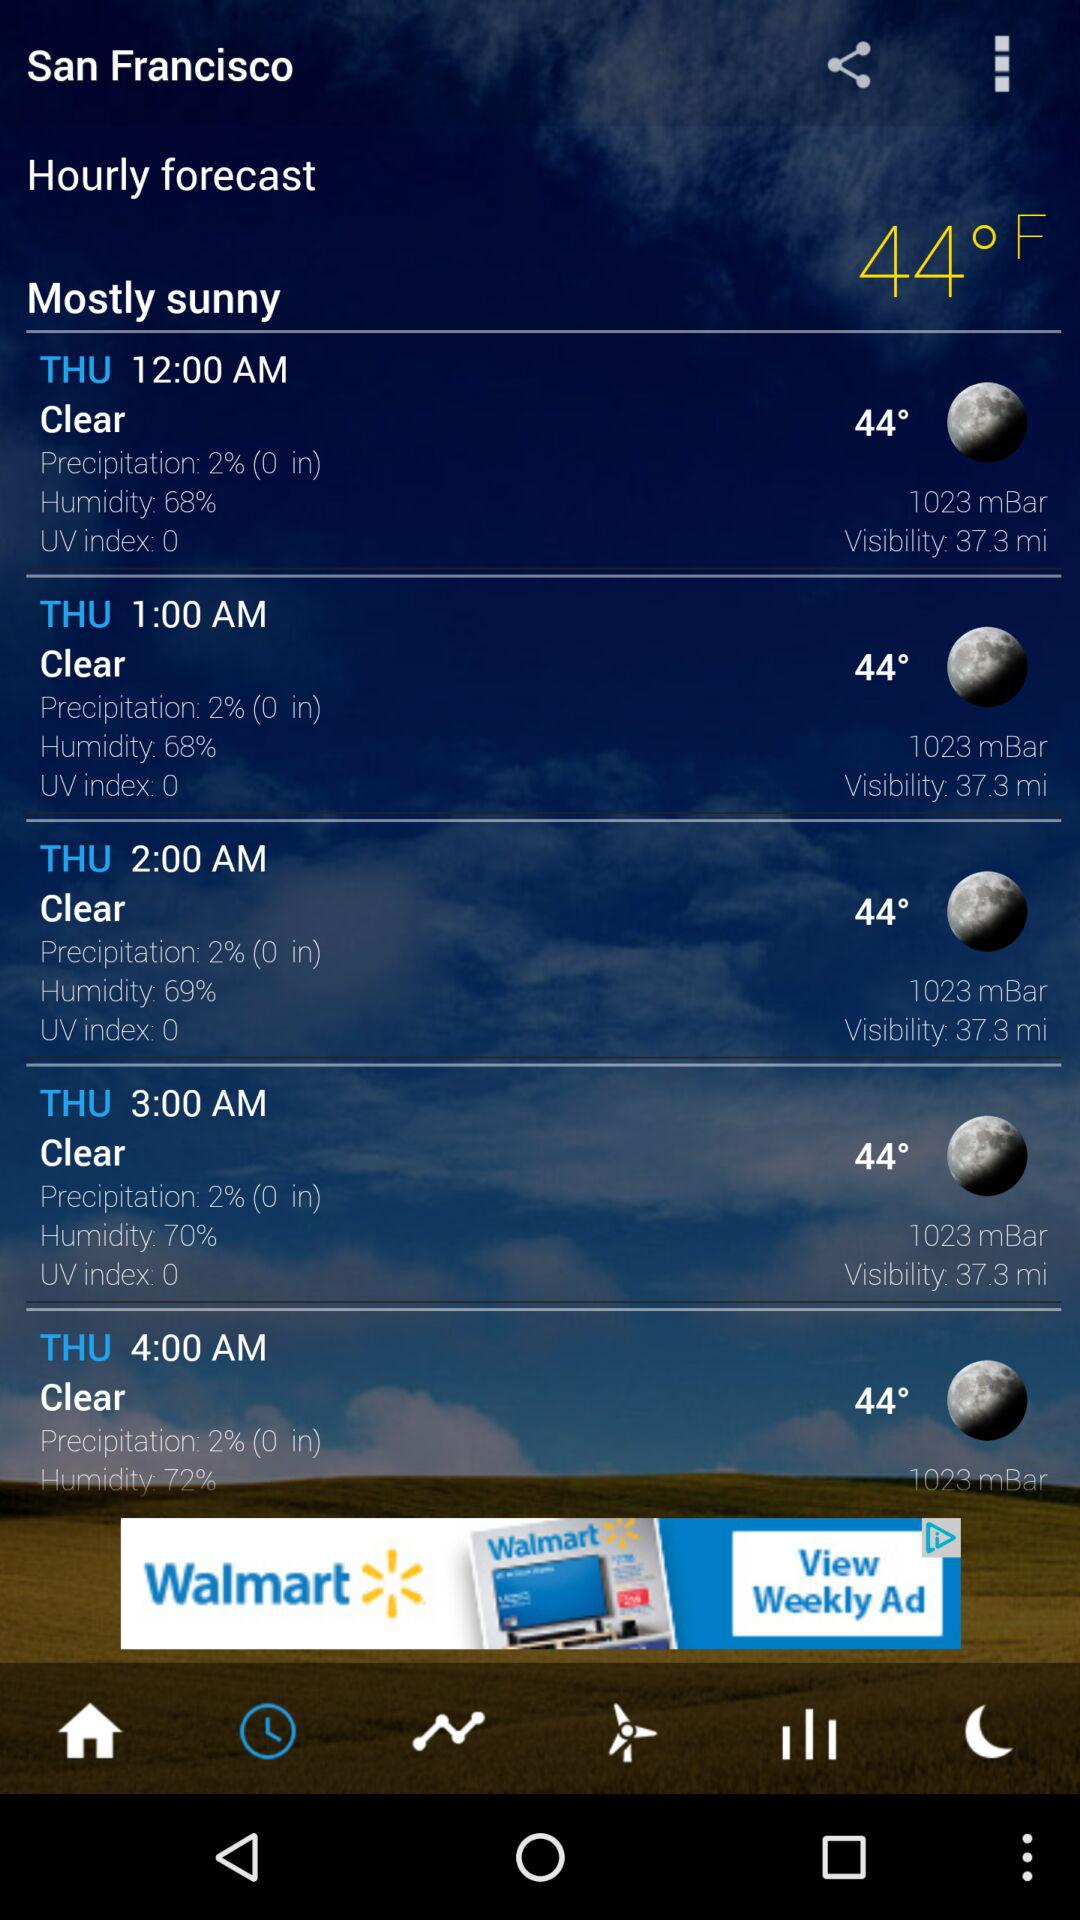What is the weather like? The weather is mostly sunny. 